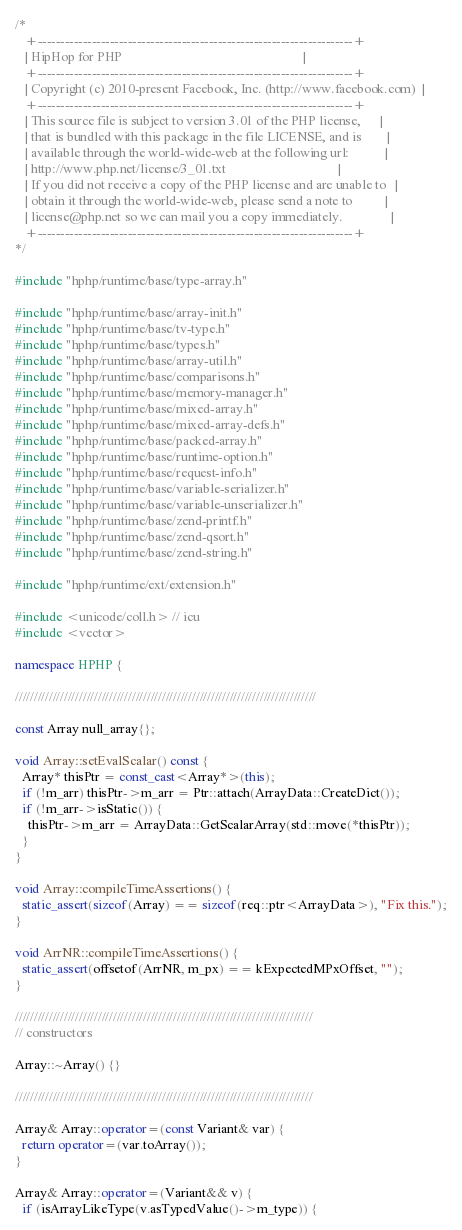<code> <loc_0><loc_0><loc_500><loc_500><_C++_>/*
   +----------------------------------------------------------------------+
   | HipHop for PHP                                                       |
   +----------------------------------------------------------------------+
   | Copyright (c) 2010-present Facebook, Inc. (http://www.facebook.com)  |
   +----------------------------------------------------------------------+
   | This source file is subject to version 3.01 of the PHP license,      |
   | that is bundled with this package in the file LICENSE, and is        |
   | available through the world-wide-web at the following url:           |
   | http://www.php.net/license/3_01.txt                                  |
   | If you did not receive a copy of the PHP license and are unable to   |
   | obtain it through the world-wide-web, please send a note to          |
   | license@php.net so we can mail you a copy immediately.               |
   +----------------------------------------------------------------------+
*/

#include "hphp/runtime/base/type-array.h"

#include "hphp/runtime/base/array-init.h"
#include "hphp/runtime/base/tv-type.h"
#include "hphp/runtime/base/types.h"
#include "hphp/runtime/base/array-util.h"
#include "hphp/runtime/base/comparisons.h"
#include "hphp/runtime/base/memory-manager.h"
#include "hphp/runtime/base/mixed-array.h"
#include "hphp/runtime/base/mixed-array-defs.h"
#include "hphp/runtime/base/packed-array.h"
#include "hphp/runtime/base/runtime-option.h"
#include "hphp/runtime/base/request-info.h"
#include "hphp/runtime/base/variable-serializer.h"
#include "hphp/runtime/base/variable-unserializer.h"
#include "hphp/runtime/base/zend-printf.h"
#include "hphp/runtime/base/zend-qsort.h"
#include "hphp/runtime/base/zend-string.h"

#include "hphp/runtime/ext/extension.h"

#include <unicode/coll.h> // icu
#include <vector>

namespace HPHP {

////////////////////////////////////////////////////////////////////////////////

const Array null_array{};

void Array::setEvalScalar() const {
  Array* thisPtr = const_cast<Array*>(this);
  if (!m_arr) thisPtr->m_arr = Ptr::attach(ArrayData::CreateDict());
  if (!m_arr->isStatic()) {
    thisPtr->m_arr = ArrayData::GetScalarArray(std::move(*thisPtr));
  }
}

void Array::compileTimeAssertions() {
  static_assert(sizeof(Array) == sizeof(req::ptr<ArrayData>), "Fix this.");
}

void ArrNR::compileTimeAssertions() {
  static_assert(offsetof(ArrNR, m_px) == kExpectedMPxOffset, "");
}

///////////////////////////////////////////////////////////////////////////////
// constructors

Array::~Array() {}

///////////////////////////////////////////////////////////////////////////////

Array& Array::operator=(const Variant& var) {
  return operator=(var.toArray());
}

Array& Array::operator=(Variant&& v) {
  if (isArrayLikeType(v.asTypedValue()->m_type)) {</code> 